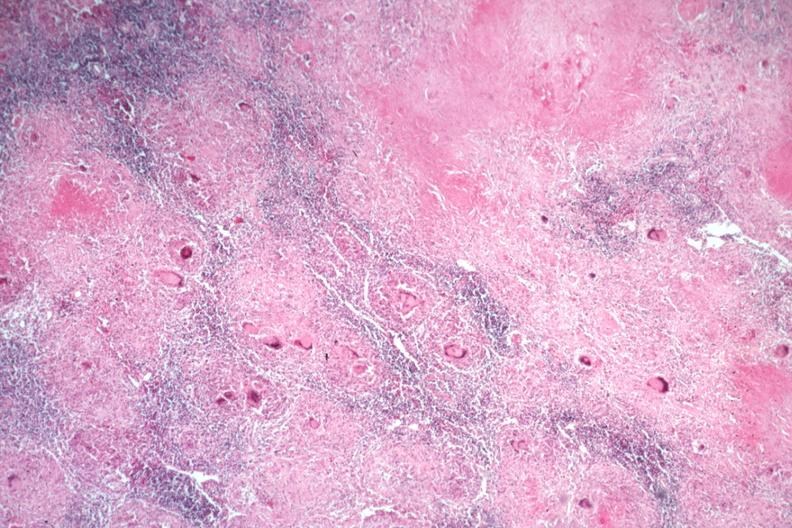s tuberculosis present?
Answer the question using a single word or phrase. Yes 